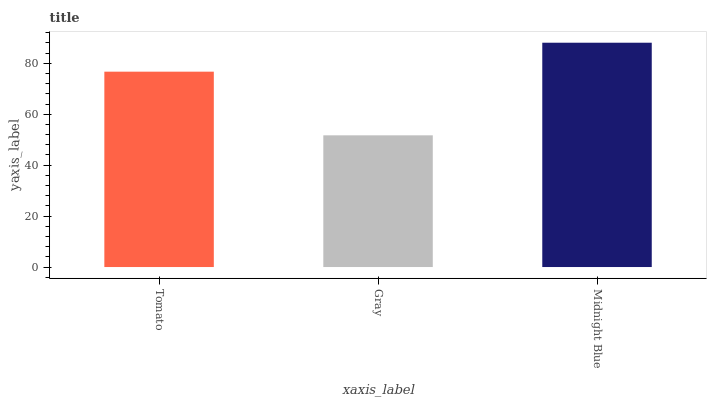Is Gray the minimum?
Answer yes or no. Yes. Is Midnight Blue the maximum?
Answer yes or no. Yes. Is Midnight Blue the minimum?
Answer yes or no. No. Is Gray the maximum?
Answer yes or no. No. Is Midnight Blue greater than Gray?
Answer yes or no. Yes. Is Gray less than Midnight Blue?
Answer yes or no. Yes. Is Gray greater than Midnight Blue?
Answer yes or no. No. Is Midnight Blue less than Gray?
Answer yes or no. No. Is Tomato the high median?
Answer yes or no. Yes. Is Tomato the low median?
Answer yes or no. Yes. Is Midnight Blue the high median?
Answer yes or no. No. Is Midnight Blue the low median?
Answer yes or no. No. 